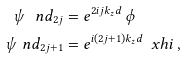<formula> <loc_0><loc_0><loc_500><loc_500>\psi \ n d _ { 2 j } & = e ^ { 2 i j k _ { z } d } \, \phi \\ \psi \ n d _ { 2 j + 1 } & = e ^ { i ( 2 j + 1 ) k _ { z } d } \, \ x h i \ ,</formula> 